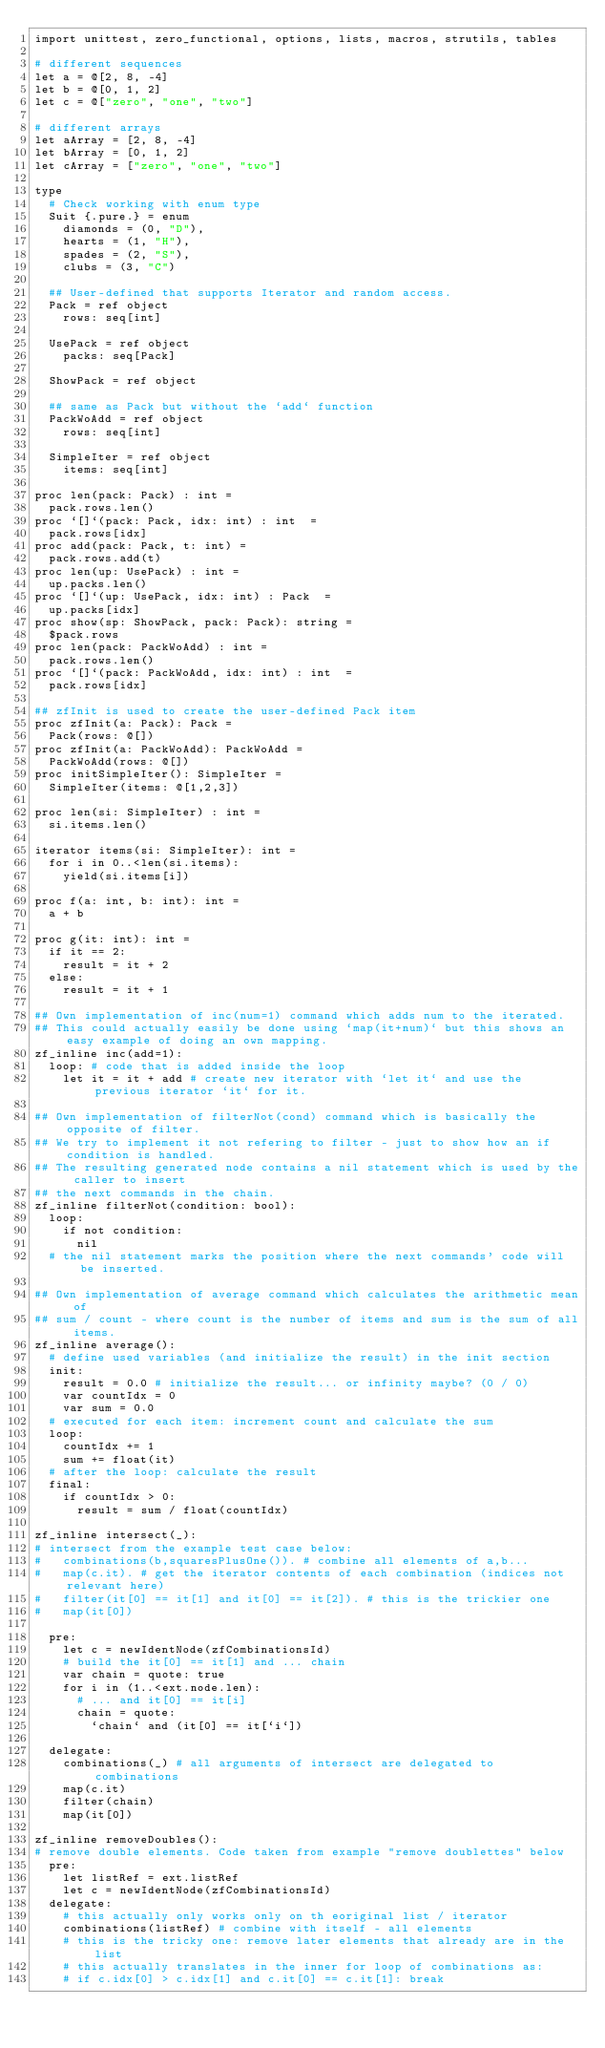Convert code to text. <code><loc_0><loc_0><loc_500><loc_500><_Nim_>import unittest, zero_functional, options, lists, macros, strutils, tables

# different sequences
let a = @[2, 8, -4]
let b = @[0, 1, 2]
let c = @["zero", "one", "two"]

# different arrays
let aArray = [2, 8, -4]
let bArray = [0, 1, 2]
let cArray = ["zero", "one", "two"]

type 
  # Check working with enum type
  Suit {.pure.} = enum
    diamonds = (0, "D"),
    hearts = (1, "H"), 
    spades = (2, "S"), 
    clubs = (3, "C")

  ## User-defined that supports Iterator and random access. 
  Pack = ref object
    rows: seq[int]

  UsePack = ref object
    packs: seq[Pack]

  ShowPack = ref object
  
  ## same as Pack but without the `add` function
  PackWoAdd = ref object
    rows: seq[int]

  SimpleIter = ref object
    items: seq[int]
  
proc len(pack: Pack) : int = 
  pack.rows.len()
proc `[]`(pack: Pack, idx: int) : int  = 
  pack.rows[idx]
proc add(pack: Pack, t: int) = 
  pack.rows.add(t)
proc len(up: UsePack) : int = 
  up.packs.len()
proc `[]`(up: UsePack, idx: int) : Pack  = 
  up.packs[idx]
proc show(sp: ShowPack, pack: Pack): string = 
  $pack.rows
proc len(pack: PackWoAdd) : int = 
  pack.rows.len()
proc `[]`(pack: PackWoAdd, idx: int) : int  = 
  pack.rows[idx]
  
## zfInit is used to create the user-defined Pack item
proc zfInit(a: Pack): Pack =
  Pack(rows: @[])
proc zfInit(a: PackWoAdd): PackWoAdd =
  PackWoAdd(rows: @[])
proc initSimpleIter(): SimpleIter =
  SimpleIter(items: @[1,2,3])

proc len(si: SimpleIter) : int = 
  si.items.len()

iterator items(si: SimpleIter): int =
  for i in 0..<len(si.items):
    yield(si.items[i])

proc f(a: int, b: int): int =
  a + b

proc g(it: int): int =
  if it == 2:
    result = it + 2
  else:
    result = it + 1

## Own implementation of inc(num=1) command which adds num to the iterated.
## This could actually easily be done using `map(it+num)` but this shows an easy example of doing an own mapping.
zf_inline inc(add=1):
  loop: # code that is added inside the loop
    let it = it + add # create new iterator with `let it` and use the previous iterator `it` for it. 

## Own implementation of filterNot(cond) command which is basically the opposite of filter.
## We try to implement it not refering to filter - just to show how an if condition is handled.
## The resulting generated node contains a nil statement which is used by the caller to insert
## the next commands in the chain.
zf_inline filterNot(condition: bool):
  loop:
    if not condition:
      nil
  # the nil statement marks the position where the next commands' code will be inserted.

## Own implementation of average command which calculates the arithmetic mean of 
## sum / count - where count is the number of items and sum is the sum of all items.
zf_inline average():
  # define used variables (and initialize the result) in the init section
  init: 
    result = 0.0 # initialize the result... or infinity maybe? (0 / 0)
    var countIdx = 0
    var sum = 0.0
  # executed for each item: increment count and calculate the sum
  loop:
    countIdx += 1
    sum += float(it)
  # after the loop: calculate the result
  final: 
    if countIdx > 0:
      result = sum / float(countIdx)

zf_inline intersect(_):
# intersect from the example test case below:
#   combinations(b,squaresPlusOne()). # combine all elements of a,b...
#   map(c.it). # get the iterator contents of each combination (indices not relevant here)
#   filter(it[0] == it[1] and it[0] == it[2]). # this is the trickier one
#   map(it[0])

  pre:
    let c = newIdentNode(zfCombinationsId)
    # build the it[0] == it[1] and ... chain
    var chain = quote: true
    for i in (1..<ext.node.len):
      # ... and it[0] == it[i]
      chain = quote:
        `chain` and (it[0] == it[`i`])

  delegate:
    combinations(_) # all arguments of intersect are delegated to combinations
    map(c.it)
    filter(chain)
    map(it[0])

zf_inline removeDoubles():
# remove double elements. Code taken from example "remove doublettes" below
  pre:
    let listRef = ext.listRef
    let c = newIdentNode(zfCombinationsId)
  delegate:
    # this actually only works only on th eoriginal list / iterator
    combinations(listRef) # combine with itself - all elements
    # this is the tricky one: remove later elements that already are in the list
    # this actually translates in the inner for loop of combinations as:
    # if c.idx[0] > c.idx[1] and c.it[0] == c.it[1]: break</code> 